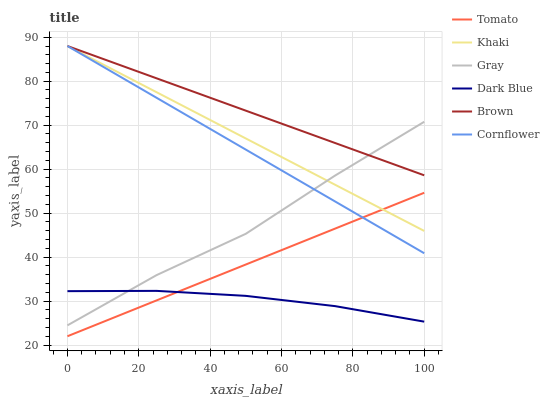Does Dark Blue have the minimum area under the curve?
Answer yes or no. Yes. Does Brown have the maximum area under the curve?
Answer yes or no. Yes. Does Gray have the minimum area under the curve?
Answer yes or no. No. Does Gray have the maximum area under the curve?
Answer yes or no. No. Is Tomato the smoothest?
Answer yes or no. Yes. Is Gray the roughest?
Answer yes or no. Yes. Is Khaki the smoothest?
Answer yes or no. No. Is Khaki the roughest?
Answer yes or no. No. Does Tomato have the lowest value?
Answer yes or no. Yes. Does Gray have the lowest value?
Answer yes or no. No. Does Cornflower have the highest value?
Answer yes or no. Yes. Does Gray have the highest value?
Answer yes or no. No. Is Dark Blue less than Khaki?
Answer yes or no. Yes. Is Gray greater than Tomato?
Answer yes or no. Yes. Does Gray intersect Cornflower?
Answer yes or no. Yes. Is Gray less than Cornflower?
Answer yes or no. No. Is Gray greater than Cornflower?
Answer yes or no. No. Does Dark Blue intersect Khaki?
Answer yes or no. No. 